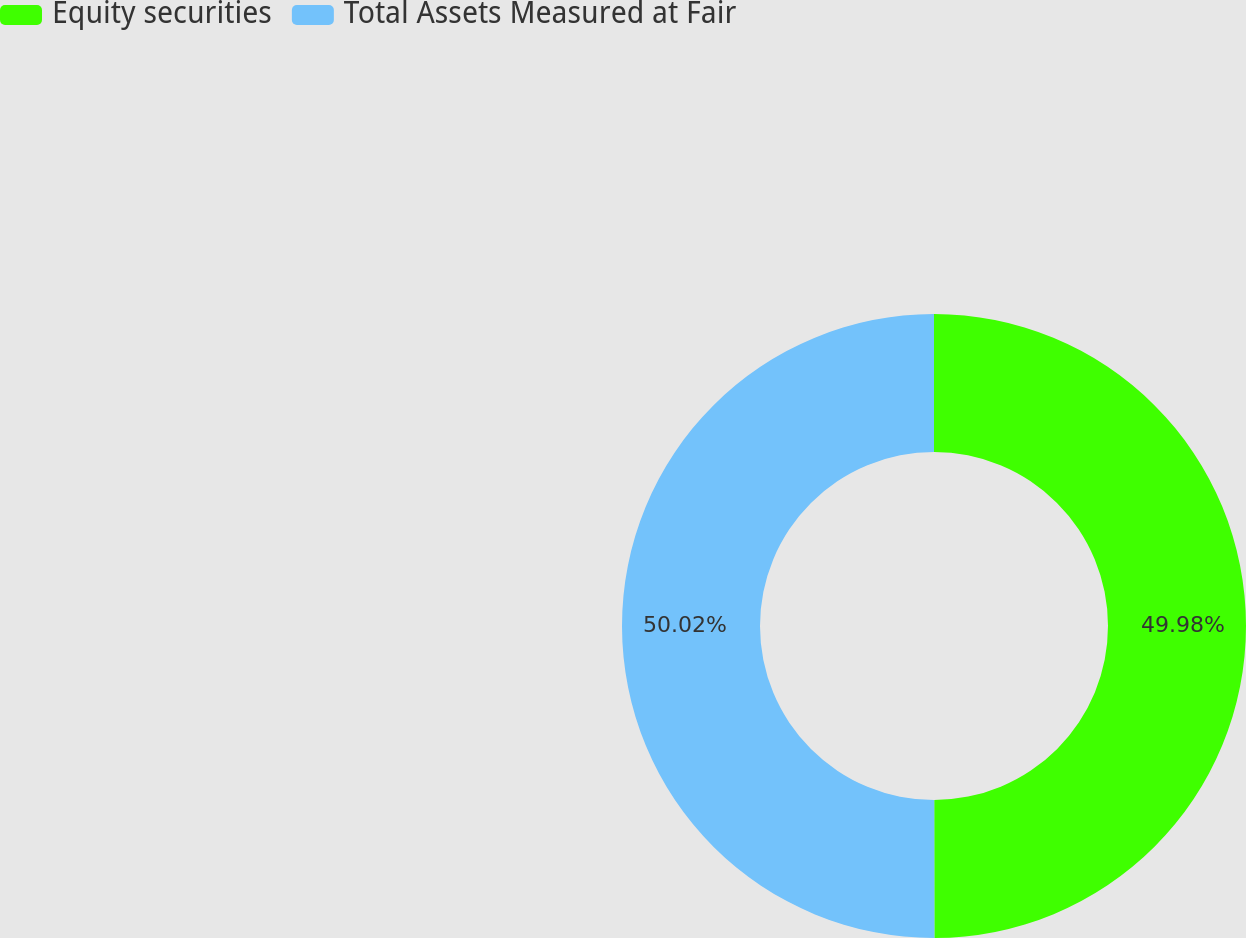Convert chart to OTSL. <chart><loc_0><loc_0><loc_500><loc_500><pie_chart><fcel>Equity securities<fcel>Total Assets Measured at Fair<nl><fcel>49.98%<fcel>50.02%<nl></chart> 